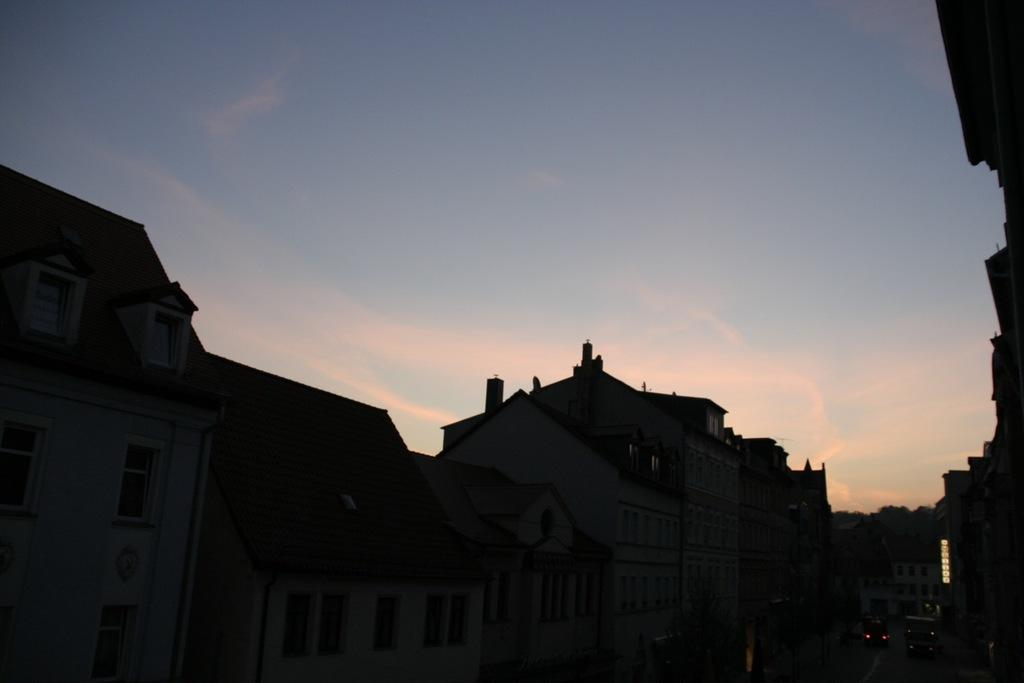What type of structures can be seen in the image? There are buildings in the image. What else is present in the image besides the buildings? There is a road in the image, and vehicles are moving on the road. What can be seen in the background of the image? The sky is visible in the background of the image. How would you describe the sky in the image? The sky appears to be clear in the image. What type of feast is being held in the image? There is no feast present in the image; it features buildings, a road, vehicles, and a clear sky. Are there any jeans visible in the image? There are no jeans present in the image. 